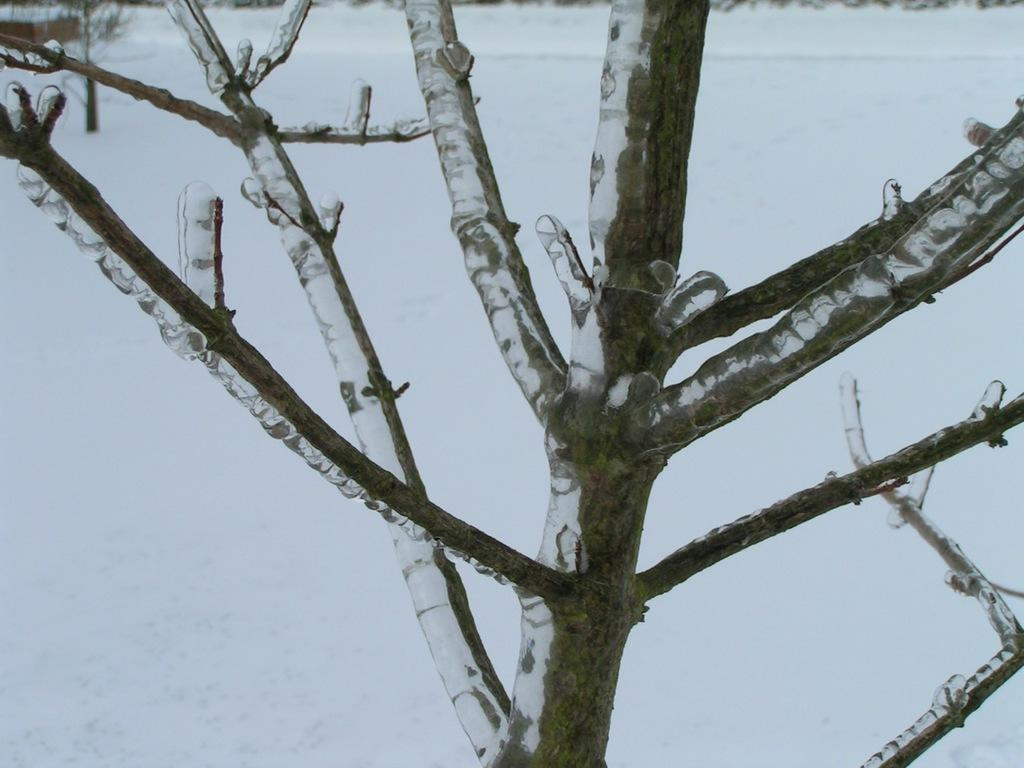What is present in the image? There is a tree in the image. What is covering the tree? There is snow on the tree. What can be seen in the background of the image? There is snow on the ground in the background of the image. What type of paste can be seen on the branches of the tree in the image? There is no paste present on the branches of the tree in the image; it is covered in snow. 